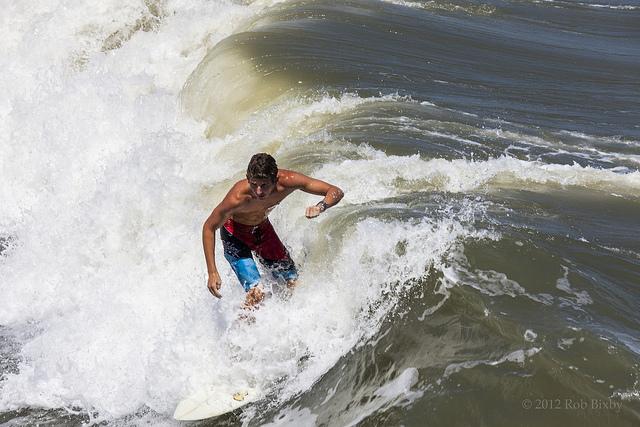What is the man wearing?
Concise answer only. Shorts. Does the man have a tattoo on his left arm?
Quick response, please. No. What is he doing on top of the water?
Give a very brief answer. Surfing. Is the man wearing a shirt?
Give a very brief answer. No. What is he wearing?
Answer briefly. Trunks. 